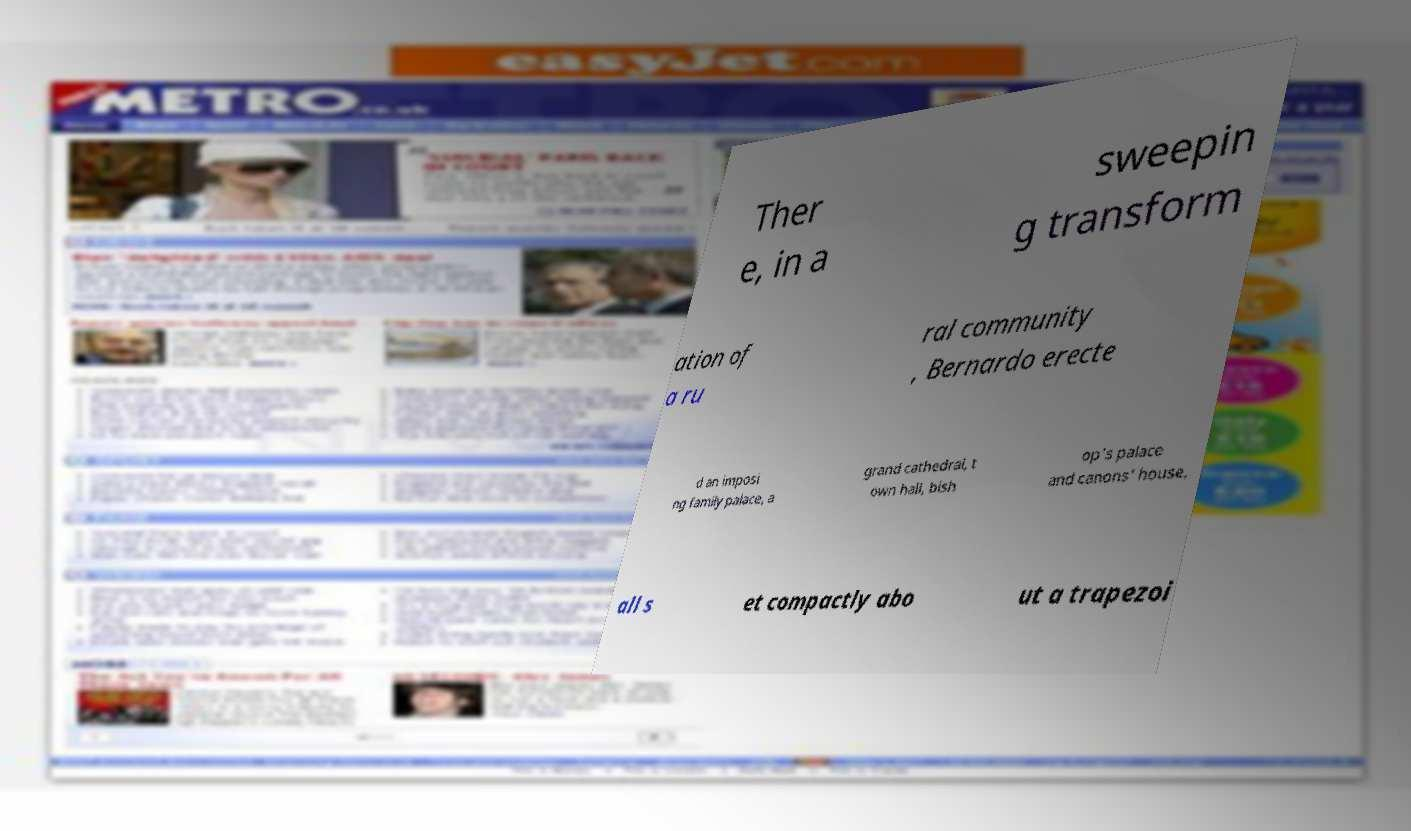I need the written content from this picture converted into text. Can you do that? Ther e, in a sweepin g transform ation of a ru ral community , Bernardo erecte d an imposi ng family palace, a grand cathedral, t own hall, bish op's palace and canons' house, all s et compactly abo ut a trapezoi 